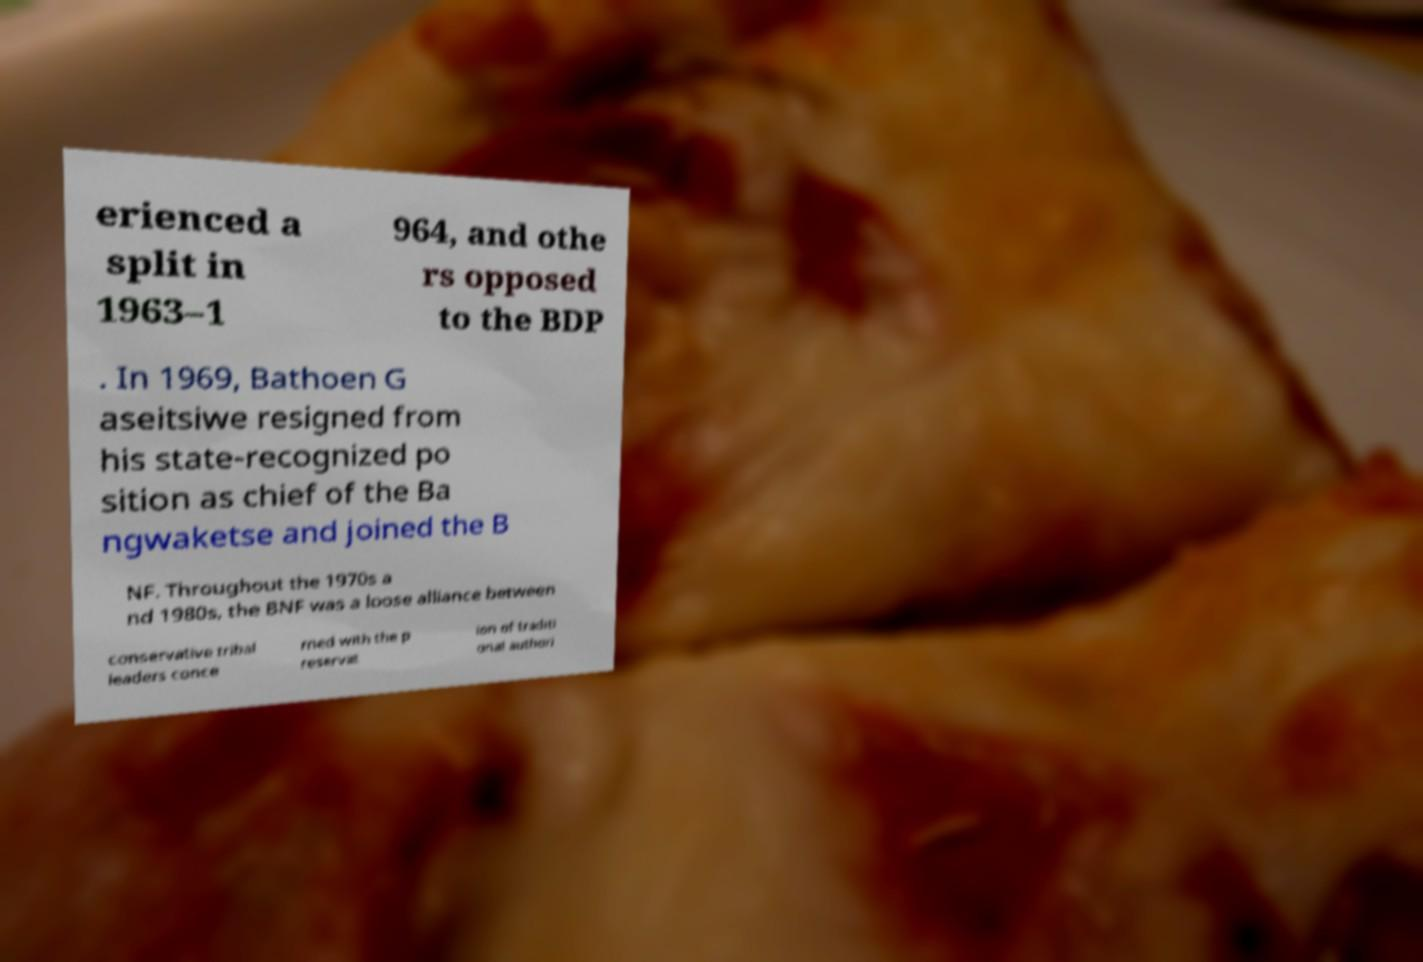There's text embedded in this image that I need extracted. Can you transcribe it verbatim? erienced a split in 1963–1 964, and othe rs opposed to the BDP . In 1969, Bathoen G aseitsiwe resigned from his state-recognized po sition as chief of the Ba ngwaketse and joined the B NF. Throughout the 1970s a nd 1980s, the BNF was a loose alliance between conservative tribal leaders conce rned with the p reservat ion of traditi onal authori 